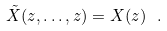<formula> <loc_0><loc_0><loc_500><loc_500>\tilde { X } ( z , \dots , z ) = X ( z ) \ .</formula> 